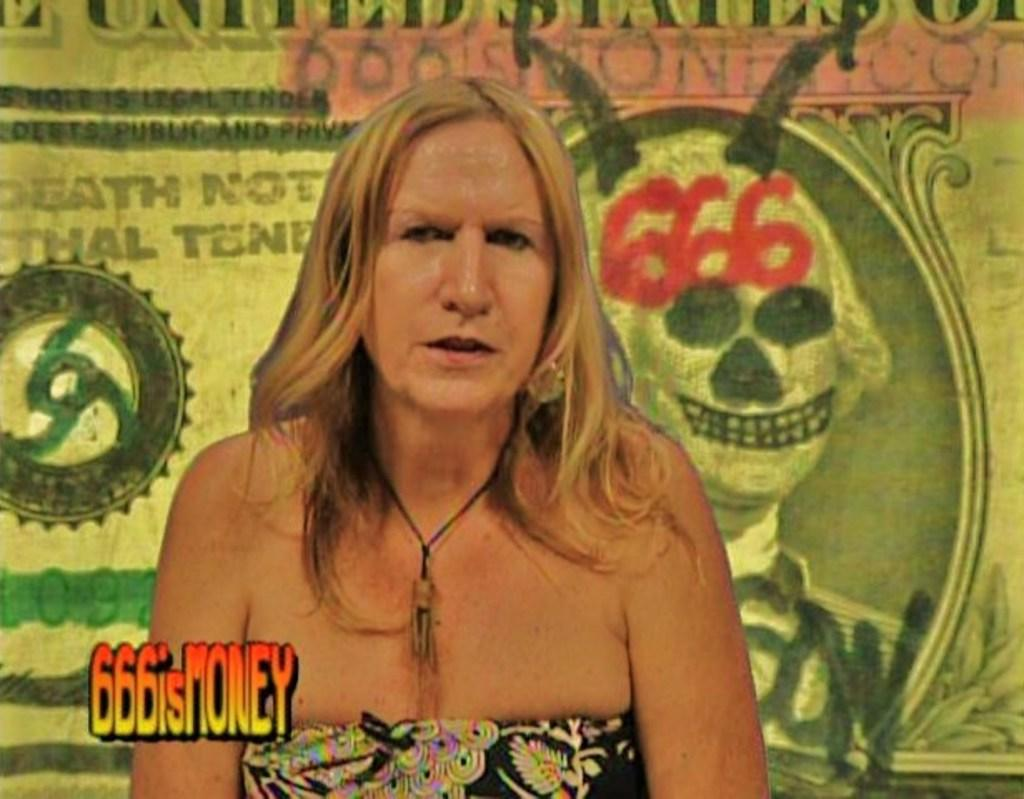What is present in the image? There is a person in the image. Can you describe the person's attire? The person is wearing a dress. What can be seen in the background of the image? There is a banner in the background of the image. What is written on the banner? There is text written on the banner. What color is the crayon being used by the person in the image? There is no crayon present in the image, so it is not possible to determine its color. 